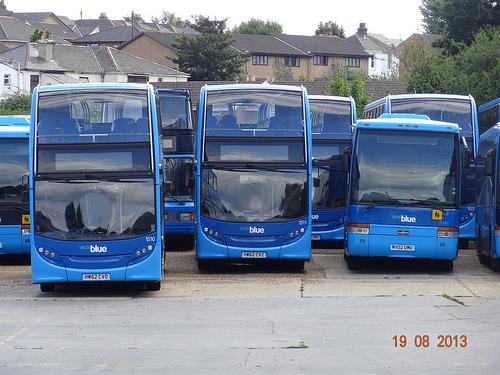Examine the bus closely and list any distinguishable features or details. Features include a black and white license plate, seats on the top row, electronic screen, headlights, amber right turn signal, a yellow warning sign, and a black windshield wiper. Identify any text present in the image and mention its characteristics. White letters spell "blue" and there's a date stamp in the corner with orange print. Count the houses in the image and describe their appearances. There are two houses: a brown brick house and a white house with a gray rooftop and a red brick chimney. Narrate the scene in the image using a poetic approach. Amidst evergreen trees, double-decker buses of blue align, their number and brand in white shining through. Behind them, a brown brick house and a white one stand, chimneys reaching skyward, bearing witness to the passage of time in orange date stamps. What is the overall feeling or mood conveyed by the image? The image conveys a sense of organized transportation in an urban setting with a touch of nature. Mention any natural element present in the image and describe its state. There's grass growing in a sidewalk crack and evergreen trees behind the buses. What type of buses can be seen in the image? There are several double decker blue buses and one regular blue bus. 